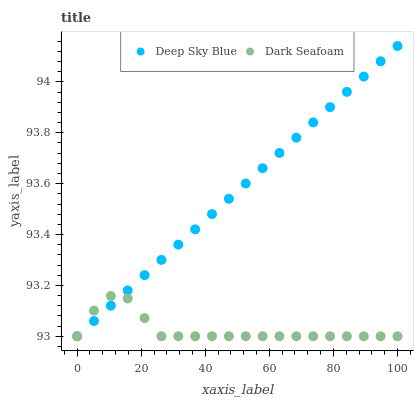Does Dark Seafoam have the minimum area under the curve?
Answer yes or no. Yes. Does Deep Sky Blue have the maximum area under the curve?
Answer yes or no. Yes. Does Deep Sky Blue have the minimum area under the curve?
Answer yes or no. No. Is Deep Sky Blue the smoothest?
Answer yes or no. Yes. Is Dark Seafoam the roughest?
Answer yes or no. Yes. Is Deep Sky Blue the roughest?
Answer yes or no. No. Does Dark Seafoam have the lowest value?
Answer yes or no. Yes. Does Deep Sky Blue have the highest value?
Answer yes or no. Yes. Does Deep Sky Blue intersect Dark Seafoam?
Answer yes or no. Yes. Is Deep Sky Blue less than Dark Seafoam?
Answer yes or no. No. Is Deep Sky Blue greater than Dark Seafoam?
Answer yes or no. No. 